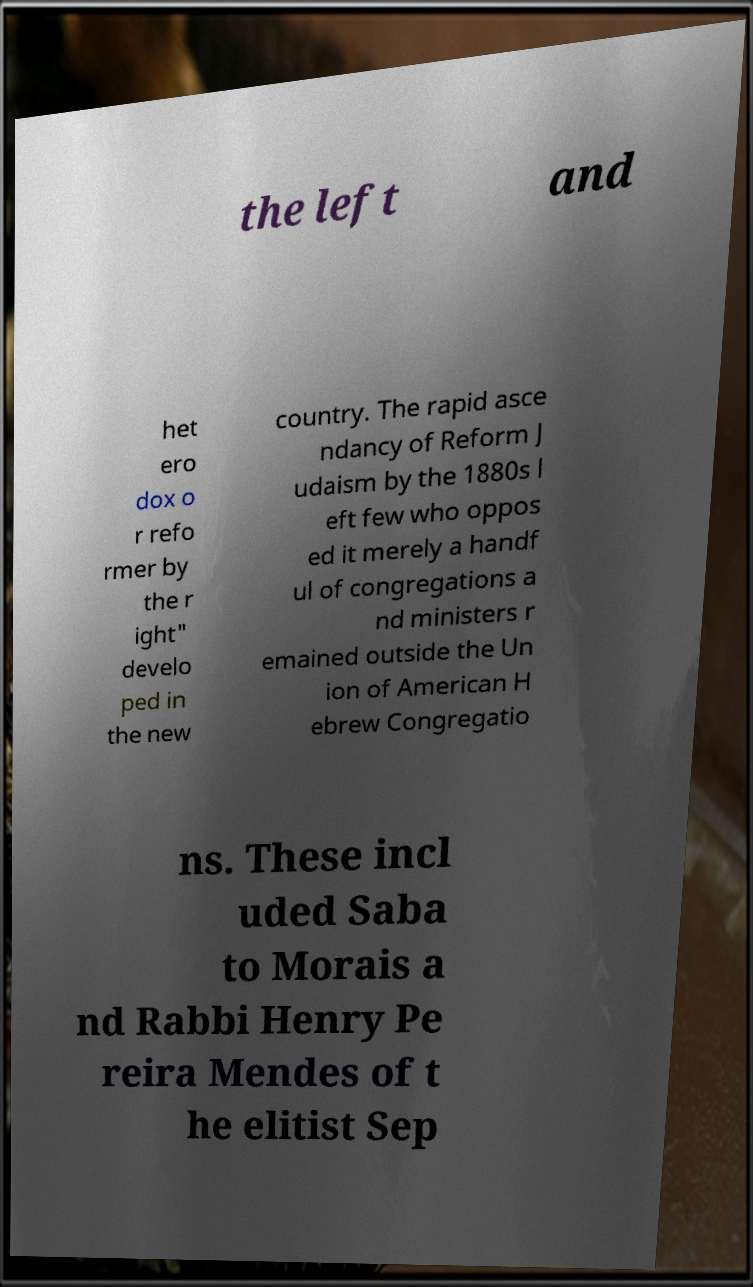Please identify and transcribe the text found in this image. the left and het ero dox o r refo rmer by the r ight" develo ped in the new country. The rapid asce ndancy of Reform J udaism by the 1880s l eft few who oppos ed it merely a handf ul of congregations a nd ministers r emained outside the Un ion of American H ebrew Congregatio ns. These incl uded Saba to Morais a nd Rabbi Henry Pe reira Mendes of t he elitist Sep 